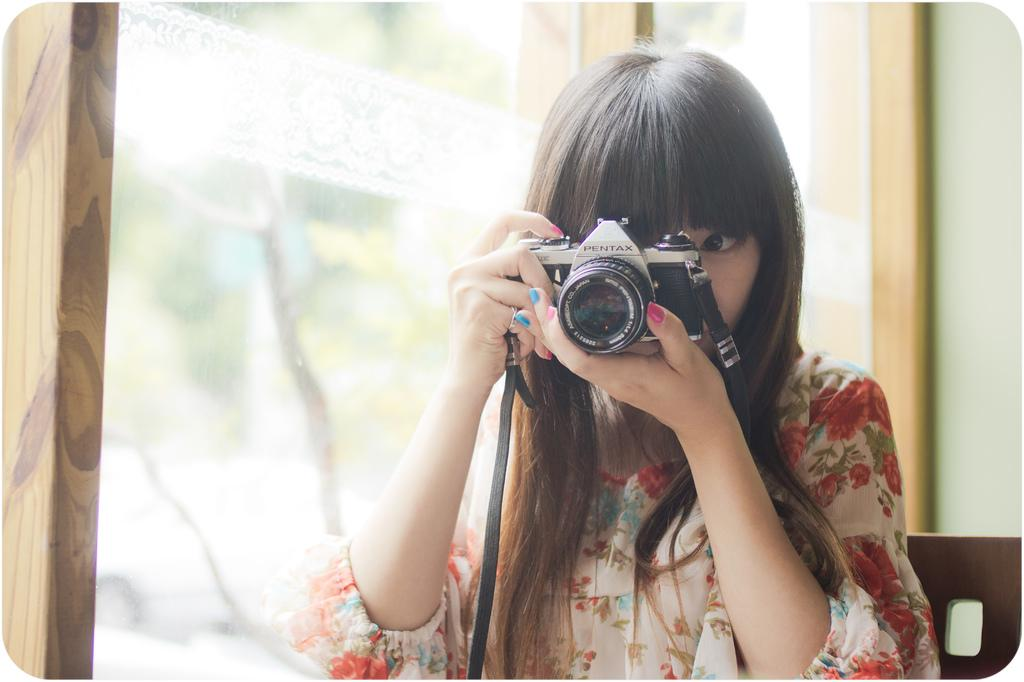Who is the main subject in the image? There is a woman in the image. What is the woman holding in the image? The woman is holding a camera. What type of quartz can be seen in the woman's hand in the image? There is no quartz present in the image; the woman is holding a camera. How many trucks are visible in the image? There are no trucks visible in the image; the main subject is a woman holding a camera. 